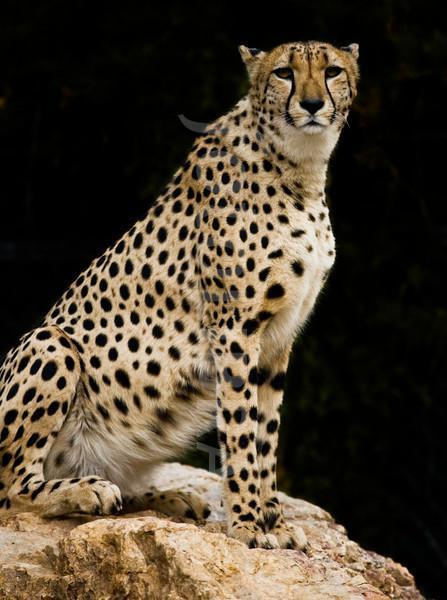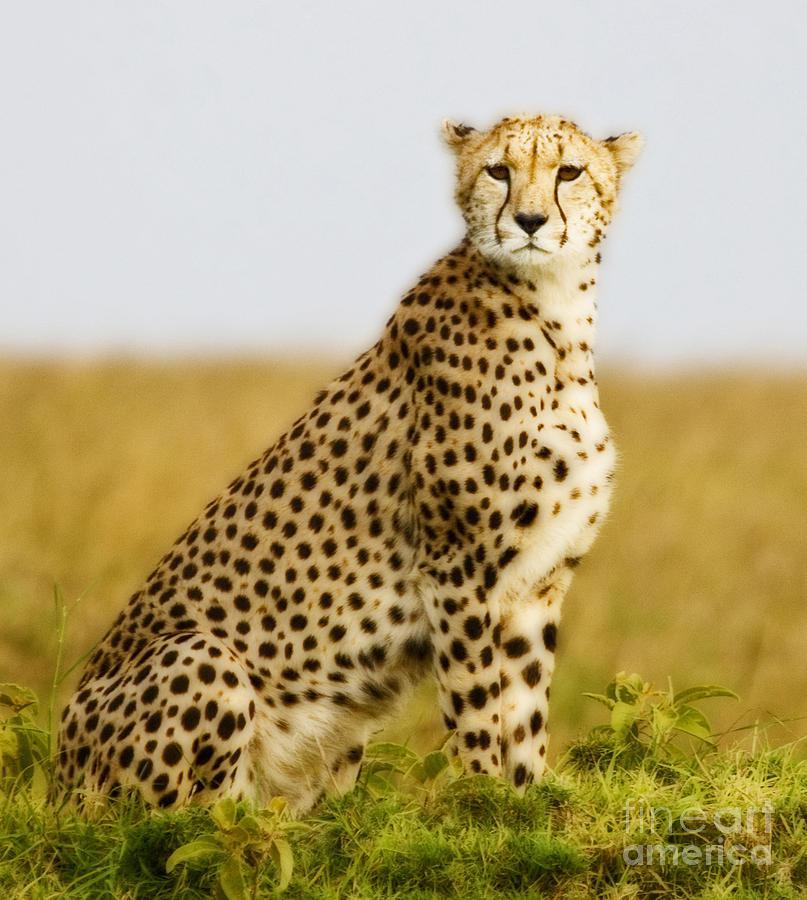The first image is the image on the left, the second image is the image on the right. Examine the images to the left and right. Is the description "There is exactly one cheetah sitting on a rock." accurate? Answer yes or no. Yes. The first image is the image on the left, the second image is the image on the right. Evaluate the accuracy of this statement regarding the images: "Each image shows a single sitting adult cheetah with its head upright and its face turned mostly forward.". Is it true? Answer yes or no. Yes. 